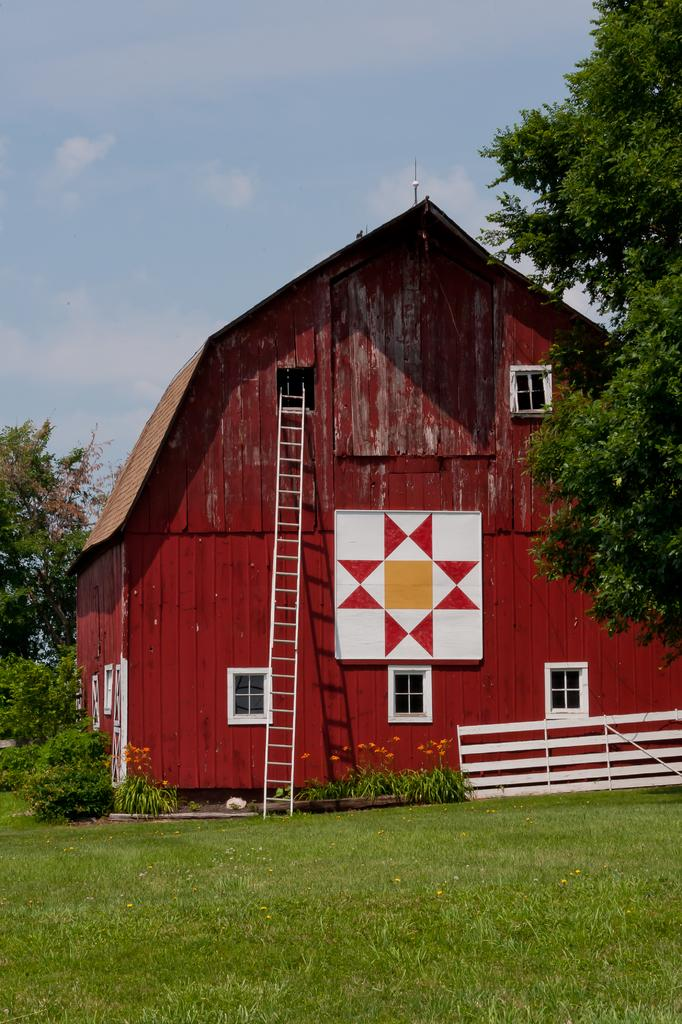What type of structure is visible in the image? There is a building in the image. What object can be seen near the building? There is a ladder in the image. What type of barrier is on the right side of the image? There is a wooden fence on the right side of the image. What can be seen in the background of the image? There are trees in the background of the image. How would you describe the weather in the image? The sky is cloudy in the image. What type of rifle is being used by the achiever in the image? There is no achiever or rifle present in the image. What is the desire of the person standing near the wooden fence in the image? There is no person or desire mentioned in the image; it only shows a building, ladder, wooden fence, trees, and a cloudy sky. 